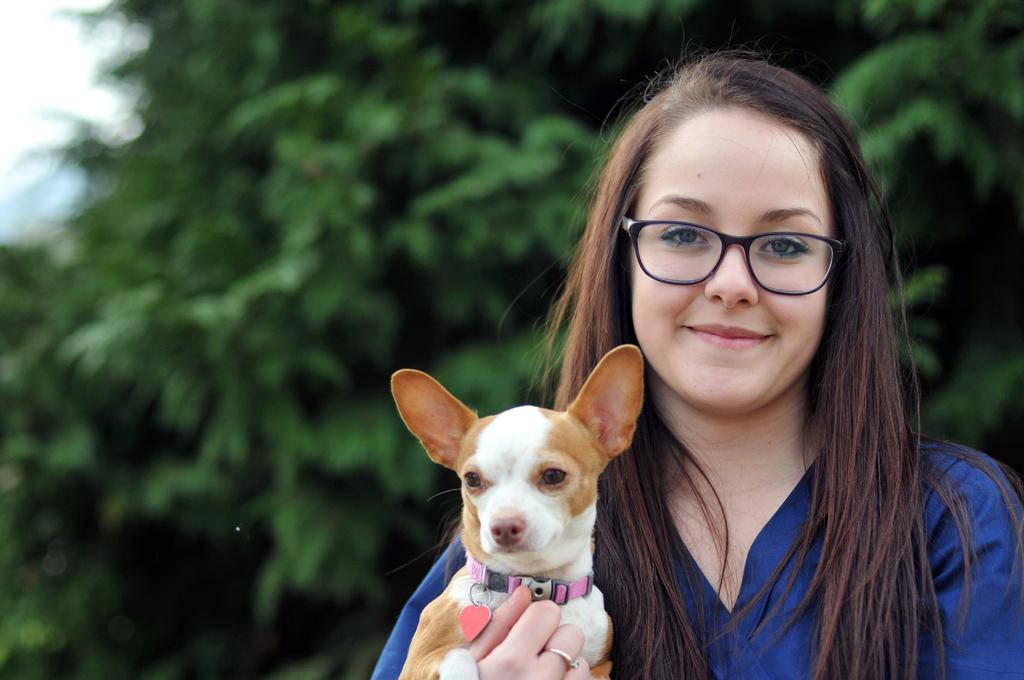Who is the main subject in the image? There is a woman in the image. What is the woman wearing? The woman is wearing spectacles. What is the woman's facial expression? The woman is smiling. What is the woman holding in the image? The woman is holding a dog with her hands. What can be seen in the background of the image? There is a tree visible in the background of the image. Where is the basin located in the image? There is no basin present in the image. What type of zipper can be seen on the woman's clothing? There is no zipper visible on the woman's clothing in the image. 